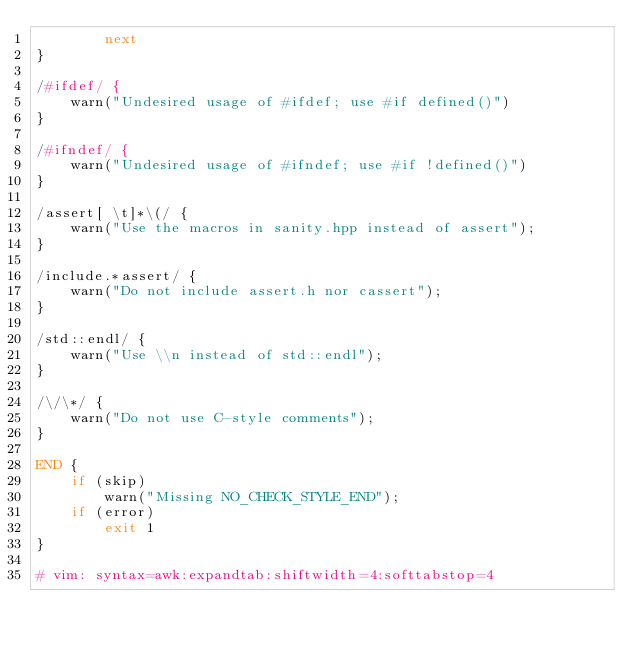<code> <loc_0><loc_0><loc_500><loc_500><_Awk_>        next
}

/#ifdef/ {
    warn("Undesired usage of #ifdef; use #if defined()")
}

/#ifndef/ {
    warn("Undesired usage of #ifndef; use #if !defined()")
}

/assert[ \t]*\(/ {
    warn("Use the macros in sanity.hpp instead of assert");
}

/include.*assert/ {
    warn("Do not include assert.h nor cassert");
}

/std::endl/ {
    warn("Use \\n instead of std::endl");
}

/\/\*/ {
    warn("Do not use C-style comments");
}

END {
    if (skip)
        warn("Missing NO_CHECK_STYLE_END");
    if (error)
        exit 1
}

# vim: syntax=awk:expandtab:shiftwidth=4:softtabstop=4
</code> 